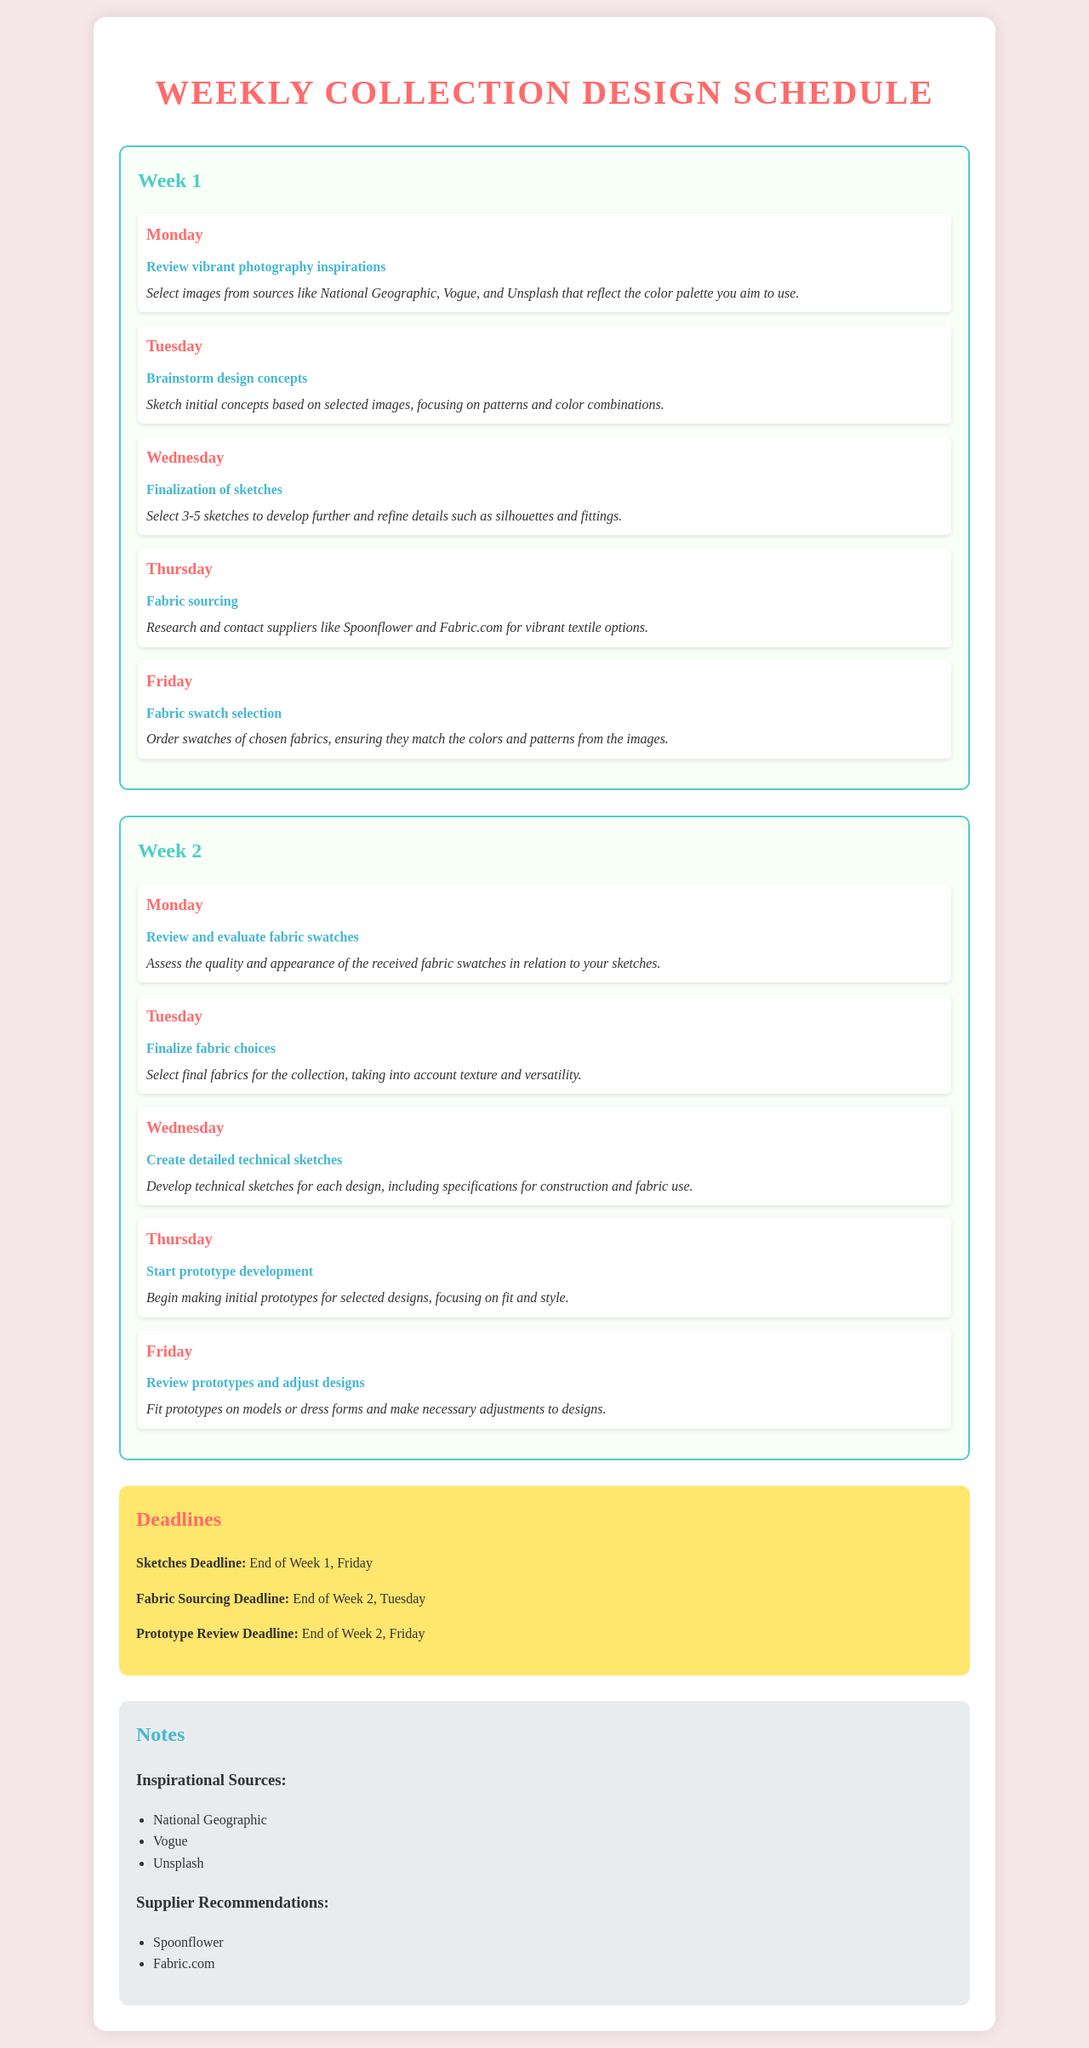What is the title of the document? The title of the document provides a summary of its content, which is the schedule of design activities.
Answer: Weekly Collection Design Schedule What activity is scheduled for Thursday of Week 1? The document outlines the specific activities planned for each day of the week.
Answer: Fabric sourcing When is the deadline for the sketches? The document specifies the deadlines for various stages of the design process.
Answer: End of Week 1, Friday How many sketches should be selected by Wednesday of Week 1? The document provides guidance on the number of initial sketches to refine.
Answer: 3-5 sketches Which suppliers are recommended for fabric sourcing? The document lists suppliers that align with the theme of vibrant colors and patterns.
Answer: Spoonflower, Fabric.com What is the focus of Tuesday's activity in Week 2? Each day's activity helps outline the design progression over the weeks.
Answer: Finalize fabric choices When should fabric swatches be reviewed? The document indicates specific days dedicated to reviewing and assessing design materials.
Answer: Monday of Week 2 What is a source of inspiration mentioned in the notes? The document lists sources that can inspire the color palette and patterns for the designs.
Answer: National Geographic What is the deadline for the fabric sourcing? The document clearly specifies the deadlines for key activities in the design schedule.
Answer: End of Week 2, Tuesday 